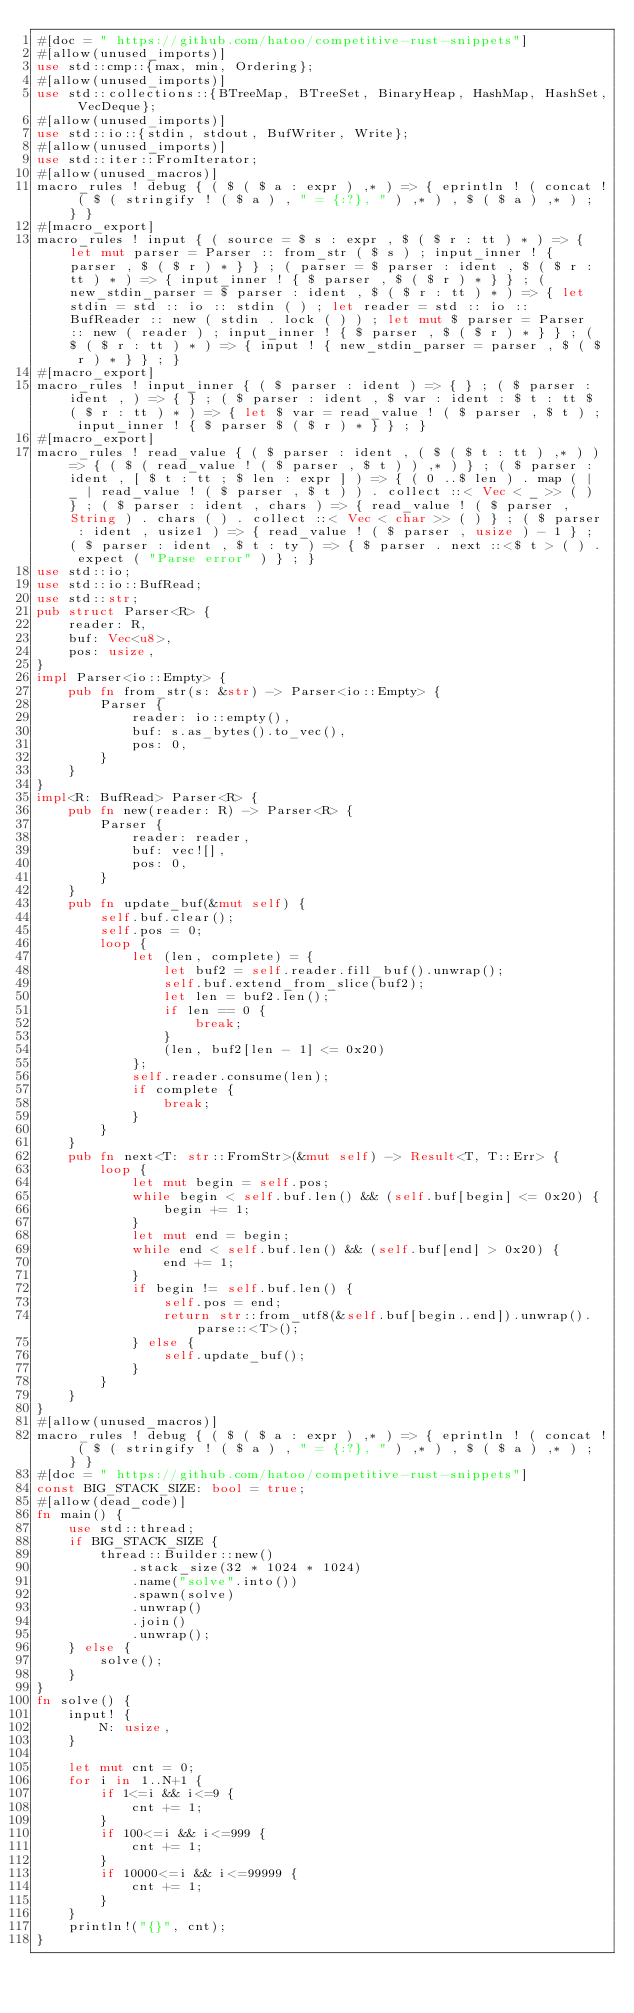Convert code to text. <code><loc_0><loc_0><loc_500><loc_500><_Rust_>#[doc = " https://github.com/hatoo/competitive-rust-snippets"]
#[allow(unused_imports)]
use std::cmp::{max, min, Ordering};
#[allow(unused_imports)]
use std::collections::{BTreeMap, BTreeSet, BinaryHeap, HashMap, HashSet, VecDeque};
#[allow(unused_imports)]
use std::io::{stdin, stdout, BufWriter, Write};
#[allow(unused_imports)]
use std::iter::FromIterator;
#[allow(unused_macros)]
macro_rules ! debug { ( $ ( $ a : expr ) ,* ) => { eprintln ! ( concat ! ( $ ( stringify ! ( $ a ) , " = {:?}, " ) ,* ) , $ ( $ a ) ,* ) ; } }
#[macro_export]
macro_rules ! input { ( source = $ s : expr , $ ( $ r : tt ) * ) => { let mut parser = Parser :: from_str ( $ s ) ; input_inner ! { parser , $ ( $ r ) * } } ; ( parser = $ parser : ident , $ ( $ r : tt ) * ) => { input_inner ! { $ parser , $ ( $ r ) * } } ; ( new_stdin_parser = $ parser : ident , $ ( $ r : tt ) * ) => { let stdin = std :: io :: stdin ( ) ; let reader = std :: io :: BufReader :: new ( stdin . lock ( ) ) ; let mut $ parser = Parser :: new ( reader ) ; input_inner ! { $ parser , $ ( $ r ) * } } ; ( $ ( $ r : tt ) * ) => { input ! { new_stdin_parser = parser , $ ( $ r ) * } } ; }
#[macro_export]
macro_rules ! input_inner { ( $ parser : ident ) => { } ; ( $ parser : ident , ) => { } ; ( $ parser : ident , $ var : ident : $ t : tt $ ( $ r : tt ) * ) => { let $ var = read_value ! ( $ parser , $ t ) ; input_inner ! { $ parser $ ( $ r ) * } } ; }
#[macro_export]
macro_rules ! read_value { ( $ parser : ident , ( $ ( $ t : tt ) ,* ) ) => { ( $ ( read_value ! ( $ parser , $ t ) ) ,* ) } ; ( $ parser : ident , [ $ t : tt ; $ len : expr ] ) => { ( 0 ..$ len ) . map ( | _ | read_value ! ( $ parser , $ t ) ) . collect ::< Vec < _ >> ( ) } ; ( $ parser : ident , chars ) => { read_value ! ( $ parser , String ) . chars ( ) . collect ::< Vec < char >> ( ) } ; ( $ parser : ident , usize1 ) => { read_value ! ( $ parser , usize ) - 1 } ; ( $ parser : ident , $ t : ty ) => { $ parser . next ::<$ t > ( ) . expect ( "Parse error" ) } ; }
use std::io;
use std::io::BufRead;
use std::str;
pub struct Parser<R> {
    reader: R,
    buf: Vec<u8>,
    pos: usize,
}
impl Parser<io::Empty> {
    pub fn from_str(s: &str) -> Parser<io::Empty> {
        Parser {
            reader: io::empty(),
            buf: s.as_bytes().to_vec(),
            pos: 0,
        }
    }
}
impl<R: BufRead> Parser<R> {
    pub fn new(reader: R) -> Parser<R> {
        Parser {
            reader: reader,
            buf: vec![],
            pos: 0,
        }
    }
    pub fn update_buf(&mut self) {
        self.buf.clear();
        self.pos = 0;
        loop {
            let (len, complete) = {
                let buf2 = self.reader.fill_buf().unwrap();
                self.buf.extend_from_slice(buf2);
                let len = buf2.len();
                if len == 0 {
                    break;
                }
                (len, buf2[len - 1] <= 0x20)
            };
            self.reader.consume(len);
            if complete {
                break;
            }
        }
    }
    pub fn next<T: str::FromStr>(&mut self) -> Result<T, T::Err> {
        loop {
            let mut begin = self.pos;
            while begin < self.buf.len() && (self.buf[begin] <= 0x20) {
                begin += 1;
            }
            let mut end = begin;
            while end < self.buf.len() && (self.buf[end] > 0x20) {
                end += 1;
            }
            if begin != self.buf.len() {
                self.pos = end;
                return str::from_utf8(&self.buf[begin..end]).unwrap().parse::<T>();
            } else {
                self.update_buf();
            }
        }
    }
}
#[allow(unused_macros)]
macro_rules ! debug { ( $ ( $ a : expr ) ,* ) => { eprintln ! ( concat ! ( $ ( stringify ! ( $ a ) , " = {:?}, " ) ,* ) , $ ( $ a ) ,* ) ; } }
#[doc = " https://github.com/hatoo/competitive-rust-snippets"]
const BIG_STACK_SIZE: bool = true;
#[allow(dead_code)]
fn main() {
    use std::thread;
    if BIG_STACK_SIZE {
        thread::Builder::new()
            .stack_size(32 * 1024 * 1024)
            .name("solve".into())
            .spawn(solve)
            .unwrap()
            .join()
            .unwrap();
    } else {
        solve();
    }
}
fn solve() {
    input! {
        N: usize,
    }

    let mut cnt = 0;
    for i in 1..N+1 {
        if 1<=i && i<=9 {
            cnt += 1;
        }
        if 100<=i && i<=999 {
            cnt += 1;
        }
        if 10000<=i && i<=99999 {
            cnt += 1;
        }
    }
    println!("{}", cnt);
}</code> 